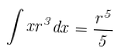<formula> <loc_0><loc_0><loc_500><loc_500>\int x r ^ { 3 } d x = \frac { r ^ { 5 } } { 5 }</formula> 